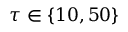Convert formula to latex. <formula><loc_0><loc_0><loc_500><loc_500>\tau \in \{ 1 0 , 5 0 \}</formula> 